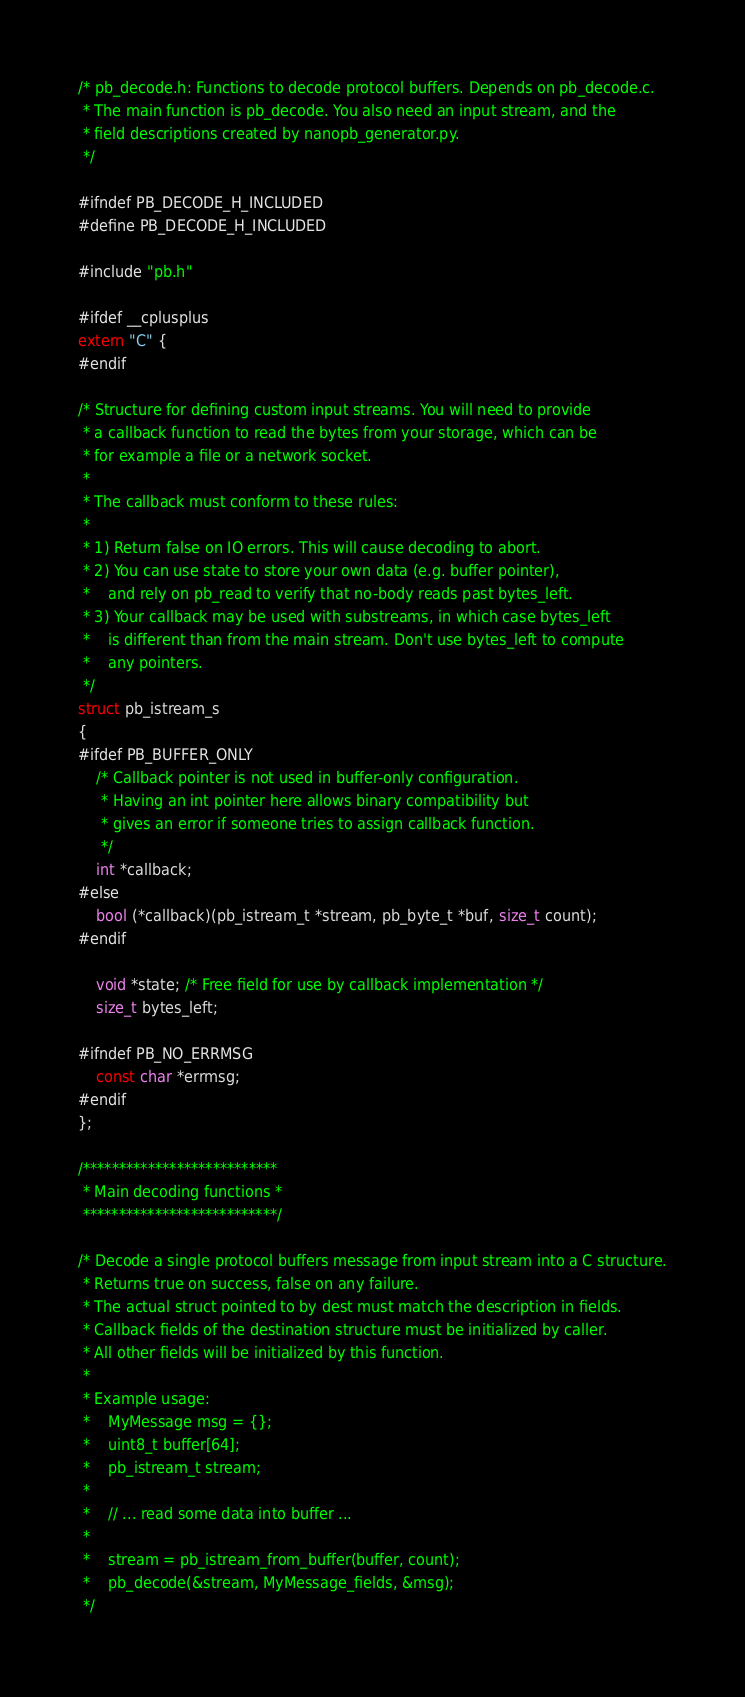<code> <loc_0><loc_0><loc_500><loc_500><_C_>/* pb_decode.h: Functions to decode protocol buffers. Depends on pb_decode.c.
 * The main function is pb_decode. You also need an input stream, and the
 * field descriptions created by nanopb_generator.py.
 */

#ifndef PB_DECODE_H_INCLUDED
#define PB_DECODE_H_INCLUDED

#include "pb.h"

#ifdef __cplusplus
extern "C" {
#endif

/* Structure for defining custom input streams. You will need to provide
 * a callback function to read the bytes from your storage, which can be
 * for example a file or a network socket.
 * 
 * The callback must conform to these rules:
 *
 * 1) Return false on IO errors. This will cause decoding to abort.
 * 2) You can use state to store your own data (e.g. buffer pointer),
 *    and rely on pb_read to verify that no-body reads past bytes_left.
 * 3) Your callback may be used with substreams, in which case bytes_left
 *    is different than from the main stream. Don't use bytes_left to compute
 *    any pointers.
 */
struct pb_istream_s
{
#ifdef PB_BUFFER_ONLY
    /* Callback pointer is not used in buffer-only configuration.
     * Having an int pointer here allows binary compatibility but
     * gives an error if someone tries to assign callback function.
     */
    int *callback;
#else
    bool (*callback)(pb_istream_t *stream, pb_byte_t *buf, size_t count);
#endif

    void *state; /* Free field for use by callback implementation */
    size_t bytes_left;
    
#ifndef PB_NO_ERRMSG
    const char *errmsg;
#endif
};

/***************************
 * Main decoding functions *
 ***************************/
 
/* Decode a single protocol buffers message from input stream into a C structure.
 * Returns true on success, false on any failure.
 * The actual struct pointed to by dest must match the description in fields.
 * Callback fields of the destination structure must be initialized by caller.
 * All other fields will be initialized by this function.
 *
 * Example usage:
 *    MyMessage msg = {};
 *    uint8_t buffer[64];
 *    pb_istream_t stream;
 *    
 *    // ... read some data into buffer ...
 *
 *    stream = pb_istream_from_buffer(buffer, count);
 *    pb_decode(&stream, MyMessage_fields, &msg);
 */</code> 